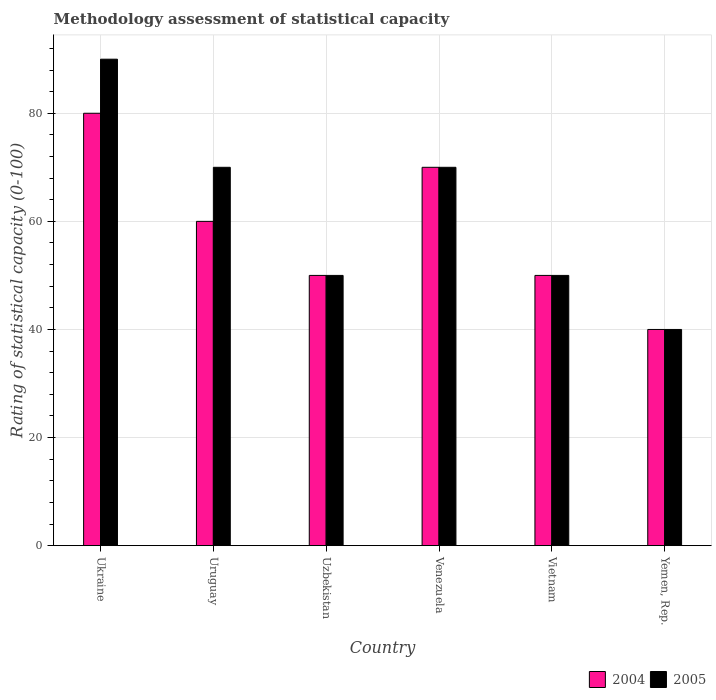How many different coloured bars are there?
Make the answer very short. 2. How many groups of bars are there?
Your response must be concise. 6. Are the number of bars on each tick of the X-axis equal?
Provide a succinct answer. Yes. How many bars are there on the 6th tick from the left?
Ensure brevity in your answer.  2. What is the label of the 5th group of bars from the left?
Offer a terse response. Vietnam. In how many cases, is the number of bars for a given country not equal to the number of legend labels?
Offer a terse response. 0. What is the rating of statistical capacity in 2004 in Uzbekistan?
Your response must be concise. 50. Across all countries, what is the minimum rating of statistical capacity in 2004?
Offer a terse response. 40. In which country was the rating of statistical capacity in 2005 maximum?
Offer a very short reply. Ukraine. In which country was the rating of statistical capacity in 2004 minimum?
Your response must be concise. Yemen, Rep. What is the total rating of statistical capacity in 2005 in the graph?
Your answer should be very brief. 370. What is the difference between the rating of statistical capacity in 2005 in Uruguay and that in Vietnam?
Offer a very short reply. 20. What is the average rating of statistical capacity in 2004 per country?
Your answer should be very brief. 58.33. What is the difference between the rating of statistical capacity of/in 2005 and rating of statistical capacity of/in 2004 in Venezuela?
Your answer should be compact. 0. In how many countries, is the rating of statistical capacity in 2005 greater than 40?
Keep it short and to the point. 5. What is the ratio of the rating of statistical capacity in 2005 in Uzbekistan to that in Yemen, Rep.?
Offer a very short reply. 1.25. Is the rating of statistical capacity in 2004 in Venezuela less than that in Yemen, Rep.?
Ensure brevity in your answer.  No. Is the difference between the rating of statistical capacity in 2005 in Uzbekistan and Venezuela greater than the difference between the rating of statistical capacity in 2004 in Uzbekistan and Venezuela?
Provide a short and direct response. No. What is the difference between the highest and the second highest rating of statistical capacity in 2004?
Give a very brief answer. 20. In how many countries, is the rating of statistical capacity in 2004 greater than the average rating of statistical capacity in 2004 taken over all countries?
Your answer should be very brief. 3. What does the 1st bar from the left in Uruguay represents?
Provide a short and direct response. 2004. What does the 2nd bar from the right in Uruguay represents?
Provide a succinct answer. 2004. How many bars are there?
Your response must be concise. 12. How many countries are there in the graph?
Provide a succinct answer. 6. Does the graph contain grids?
Your response must be concise. Yes. Where does the legend appear in the graph?
Ensure brevity in your answer.  Bottom right. What is the title of the graph?
Your response must be concise. Methodology assessment of statistical capacity. Does "2009" appear as one of the legend labels in the graph?
Your response must be concise. No. What is the label or title of the Y-axis?
Your answer should be very brief. Rating of statistical capacity (0-100). What is the Rating of statistical capacity (0-100) in 2004 in Ukraine?
Give a very brief answer. 80. What is the Rating of statistical capacity (0-100) of 2005 in Ukraine?
Your answer should be very brief. 90. What is the Rating of statistical capacity (0-100) of 2005 in Uruguay?
Your answer should be very brief. 70. What is the Rating of statistical capacity (0-100) of 2005 in Uzbekistan?
Your response must be concise. 50. What is the Rating of statistical capacity (0-100) of 2004 in Venezuela?
Offer a very short reply. 70. What is the Rating of statistical capacity (0-100) of 2005 in Venezuela?
Your answer should be compact. 70. What is the Rating of statistical capacity (0-100) in 2004 in Vietnam?
Provide a succinct answer. 50. What is the Rating of statistical capacity (0-100) of 2005 in Vietnam?
Your answer should be very brief. 50. Across all countries, what is the maximum Rating of statistical capacity (0-100) in 2004?
Ensure brevity in your answer.  80. Across all countries, what is the maximum Rating of statistical capacity (0-100) of 2005?
Offer a terse response. 90. Across all countries, what is the minimum Rating of statistical capacity (0-100) of 2004?
Provide a succinct answer. 40. Across all countries, what is the minimum Rating of statistical capacity (0-100) in 2005?
Provide a short and direct response. 40. What is the total Rating of statistical capacity (0-100) in 2004 in the graph?
Your response must be concise. 350. What is the total Rating of statistical capacity (0-100) of 2005 in the graph?
Your response must be concise. 370. What is the difference between the Rating of statistical capacity (0-100) in 2005 in Ukraine and that in Uruguay?
Keep it short and to the point. 20. What is the difference between the Rating of statistical capacity (0-100) in 2005 in Ukraine and that in Uzbekistan?
Provide a succinct answer. 40. What is the difference between the Rating of statistical capacity (0-100) of 2004 in Ukraine and that in Venezuela?
Your answer should be compact. 10. What is the difference between the Rating of statistical capacity (0-100) in 2004 in Ukraine and that in Vietnam?
Your answer should be compact. 30. What is the difference between the Rating of statistical capacity (0-100) of 2005 in Ukraine and that in Vietnam?
Offer a very short reply. 40. What is the difference between the Rating of statistical capacity (0-100) in 2004 in Ukraine and that in Yemen, Rep.?
Your answer should be very brief. 40. What is the difference between the Rating of statistical capacity (0-100) in 2005 in Ukraine and that in Yemen, Rep.?
Your answer should be very brief. 50. What is the difference between the Rating of statistical capacity (0-100) in 2005 in Uruguay and that in Uzbekistan?
Provide a short and direct response. 20. What is the difference between the Rating of statistical capacity (0-100) in 2004 in Uruguay and that in Venezuela?
Your answer should be very brief. -10. What is the difference between the Rating of statistical capacity (0-100) of 2004 in Uruguay and that in Vietnam?
Offer a very short reply. 10. What is the difference between the Rating of statistical capacity (0-100) of 2005 in Uruguay and that in Vietnam?
Ensure brevity in your answer.  20. What is the difference between the Rating of statistical capacity (0-100) of 2005 in Uruguay and that in Yemen, Rep.?
Your answer should be compact. 30. What is the difference between the Rating of statistical capacity (0-100) in 2004 in Uzbekistan and that in Venezuela?
Your answer should be compact. -20. What is the difference between the Rating of statistical capacity (0-100) in 2004 in Uzbekistan and that in Yemen, Rep.?
Give a very brief answer. 10. What is the difference between the Rating of statistical capacity (0-100) of 2005 in Venezuela and that in Vietnam?
Provide a short and direct response. 20. What is the difference between the Rating of statistical capacity (0-100) in 2005 in Venezuela and that in Yemen, Rep.?
Give a very brief answer. 30. What is the difference between the Rating of statistical capacity (0-100) of 2004 in Vietnam and that in Yemen, Rep.?
Keep it short and to the point. 10. What is the difference between the Rating of statistical capacity (0-100) of 2004 in Ukraine and the Rating of statistical capacity (0-100) of 2005 in Uzbekistan?
Your answer should be compact. 30. What is the difference between the Rating of statistical capacity (0-100) of 2004 in Ukraine and the Rating of statistical capacity (0-100) of 2005 in Venezuela?
Your response must be concise. 10. What is the difference between the Rating of statistical capacity (0-100) in 2004 in Ukraine and the Rating of statistical capacity (0-100) in 2005 in Yemen, Rep.?
Offer a very short reply. 40. What is the difference between the Rating of statistical capacity (0-100) of 2004 in Uruguay and the Rating of statistical capacity (0-100) of 2005 in Vietnam?
Provide a succinct answer. 10. What is the difference between the Rating of statistical capacity (0-100) in 2004 in Uruguay and the Rating of statistical capacity (0-100) in 2005 in Yemen, Rep.?
Keep it short and to the point. 20. What is the difference between the Rating of statistical capacity (0-100) of 2004 in Uzbekistan and the Rating of statistical capacity (0-100) of 2005 in Venezuela?
Make the answer very short. -20. What is the difference between the Rating of statistical capacity (0-100) of 2004 in Uzbekistan and the Rating of statistical capacity (0-100) of 2005 in Vietnam?
Provide a succinct answer. 0. What is the difference between the Rating of statistical capacity (0-100) in 2004 in Uzbekistan and the Rating of statistical capacity (0-100) in 2005 in Yemen, Rep.?
Give a very brief answer. 10. What is the average Rating of statistical capacity (0-100) in 2004 per country?
Offer a terse response. 58.33. What is the average Rating of statistical capacity (0-100) in 2005 per country?
Your response must be concise. 61.67. What is the difference between the Rating of statistical capacity (0-100) of 2004 and Rating of statistical capacity (0-100) of 2005 in Ukraine?
Provide a short and direct response. -10. What is the difference between the Rating of statistical capacity (0-100) in 2004 and Rating of statistical capacity (0-100) in 2005 in Venezuela?
Provide a short and direct response. 0. What is the difference between the Rating of statistical capacity (0-100) of 2004 and Rating of statistical capacity (0-100) of 2005 in Vietnam?
Your response must be concise. 0. What is the difference between the Rating of statistical capacity (0-100) in 2004 and Rating of statistical capacity (0-100) in 2005 in Yemen, Rep.?
Provide a succinct answer. 0. What is the ratio of the Rating of statistical capacity (0-100) of 2005 in Ukraine to that in Uruguay?
Your response must be concise. 1.29. What is the ratio of the Rating of statistical capacity (0-100) of 2004 in Ukraine to that in Uzbekistan?
Make the answer very short. 1.6. What is the ratio of the Rating of statistical capacity (0-100) in 2004 in Ukraine to that in Venezuela?
Your answer should be very brief. 1.14. What is the ratio of the Rating of statistical capacity (0-100) of 2004 in Ukraine to that in Yemen, Rep.?
Your response must be concise. 2. What is the ratio of the Rating of statistical capacity (0-100) in 2005 in Ukraine to that in Yemen, Rep.?
Offer a terse response. 2.25. What is the ratio of the Rating of statistical capacity (0-100) of 2004 in Uruguay to that in Uzbekistan?
Your response must be concise. 1.2. What is the ratio of the Rating of statistical capacity (0-100) of 2005 in Uruguay to that in Uzbekistan?
Offer a very short reply. 1.4. What is the ratio of the Rating of statistical capacity (0-100) in 2004 in Uruguay to that in Venezuela?
Make the answer very short. 0.86. What is the ratio of the Rating of statistical capacity (0-100) of 2005 in Uruguay to that in Venezuela?
Provide a succinct answer. 1. What is the ratio of the Rating of statistical capacity (0-100) of 2005 in Uruguay to that in Vietnam?
Ensure brevity in your answer.  1.4. What is the ratio of the Rating of statistical capacity (0-100) of 2005 in Uruguay to that in Yemen, Rep.?
Provide a succinct answer. 1.75. What is the ratio of the Rating of statistical capacity (0-100) in 2005 in Uzbekistan to that in Vietnam?
Your answer should be compact. 1. What is the ratio of the Rating of statistical capacity (0-100) of 2004 in Uzbekistan to that in Yemen, Rep.?
Offer a very short reply. 1.25. What is the ratio of the Rating of statistical capacity (0-100) in 2004 in Venezuela to that in Vietnam?
Your answer should be compact. 1.4. What is the ratio of the Rating of statistical capacity (0-100) in 2005 in Venezuela to that in Vietnam?
Ensure brevity in your answer.  1.4. What is the ratio of the Rating of statistical capacity (0-100) of 2005 in Venezuela to that in Yemen, Rep.?
Offer a very short reply. 1.75. What is the ratio of the Rating of statistical capacity (0-100) of 2004 in Vietnam to that in Yemen, Rep.?
Provide a succinct answer. 1.25. What is the ratio of the Rating of statistical capacity (0-100) in 2005 in Vietnam to that in Yemen, Rep.?
Keep it short and to the point. 1.25. What is the difference between the highest and the second highest Rating of statistical capacity (0-100) in 2004?
Provide a short and direct response. 10. What is the difference between the highest and the second highest Rating of statistical capacity (0-100) of 2005?
Offer a terse response. 20. What is the difference between the highest and the lowest Rating of statistical capacity (0-100) in 2005?
Provide a succinct answer. 50. 